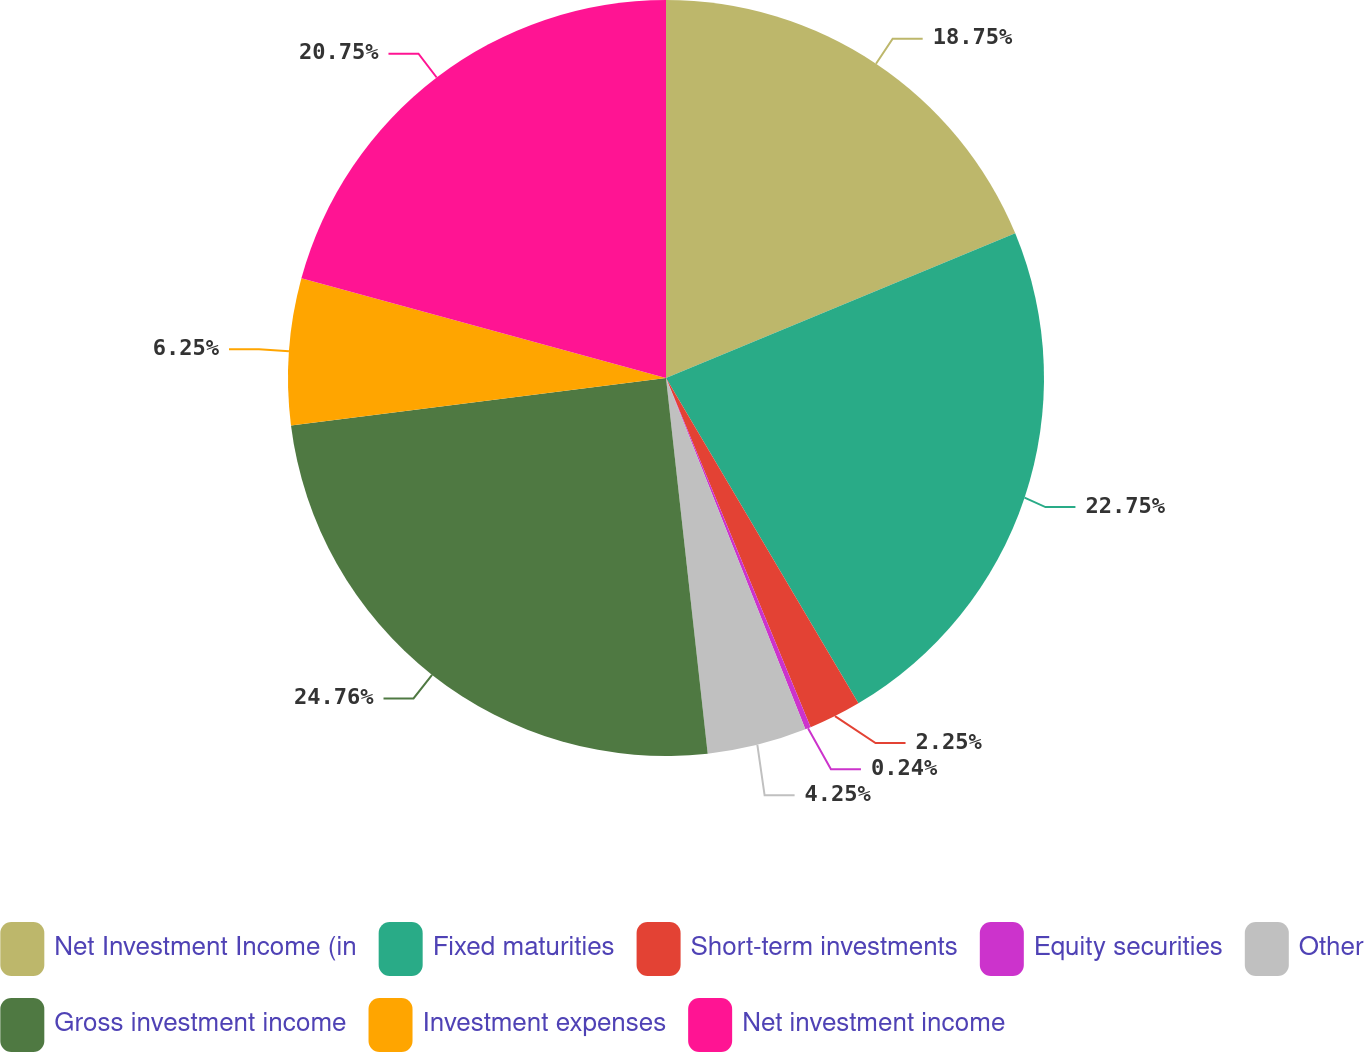Convert chart to OTSL. <chart><loc_0><loc_0><loc_500><loc_500><pie_chart><fcel>Net Investment Income (in<fcel>Fixed maturities<fcel>Short-term investments<fcel>Equity securities<fcel>Other<fcel>Gross investment income<fcel>Investment expenses<fcel>Net investment income<nl><fcel>18.75%<fcel>22.75%<fcel>2.25%<fcel>0.24%<fcel>4.25%<fcel>24.76%<fcel>6.25%<fcel>20.75%<nl></chart> 